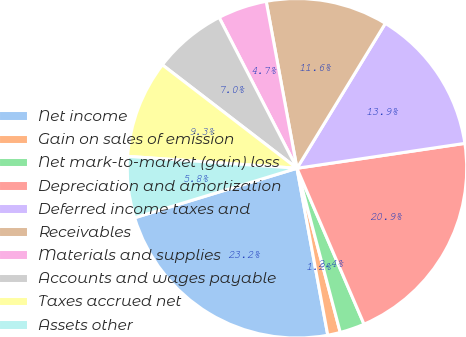<chart> <loc_0><loc_0><loc_500><loc_500><pie_chart><fcel>Net income<fcel>Gain on sales of emission<fcel>Net mark-to-market (gain) loss<fcel>Depreciation and amortization<fcel>Deferred income taxes and<fcel>Receivables<fcel>Materials and supplies<fcel>Accounts and wages payable<fcel>Taxes accrued net<fcel>Assets other<nl><fcel>23.2%<fcel>1.2%<fcel>2.36%<fcel>20.88%<fcel>13.94%<fcel>11.62%<fcel>4.68%<fcel>6.99%<fcel>9.31%<fcel>5.83%<nl></chart> 